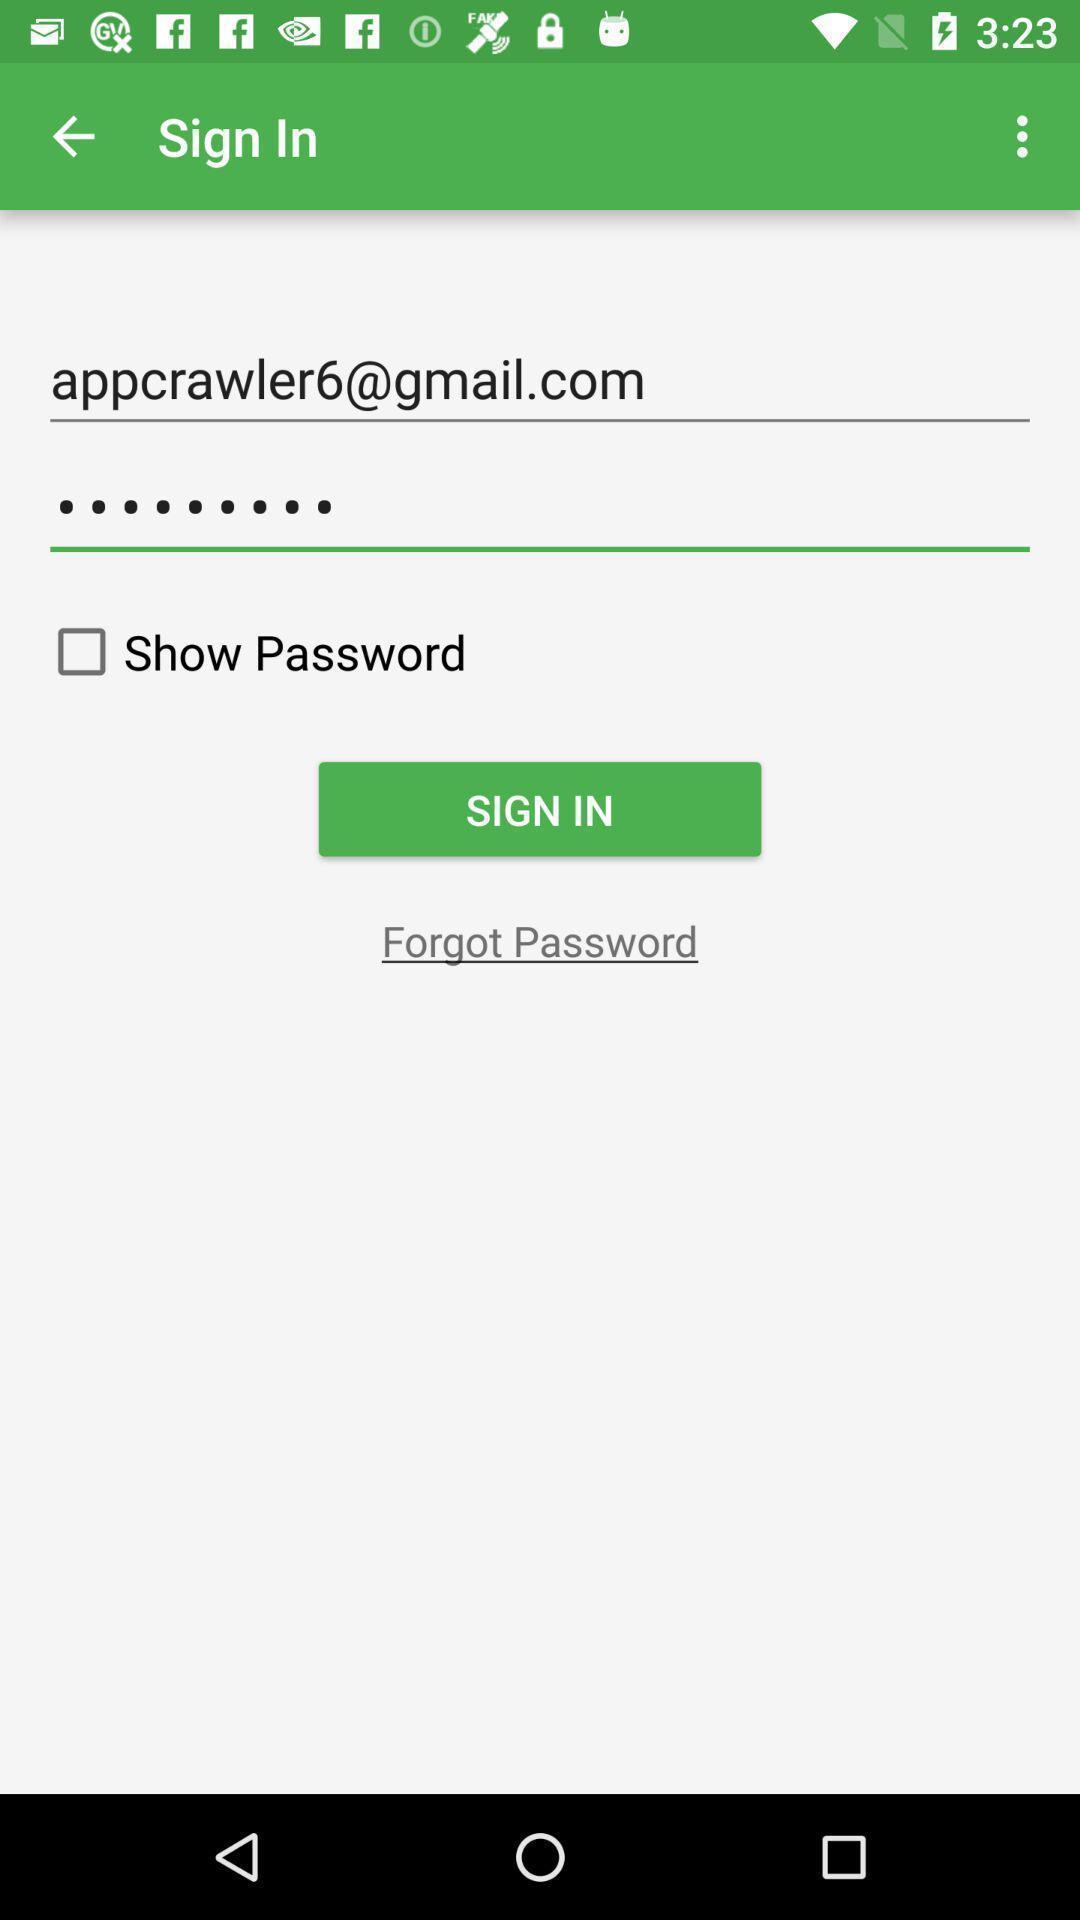Please provide a description for this image. Sign in page of the app. 